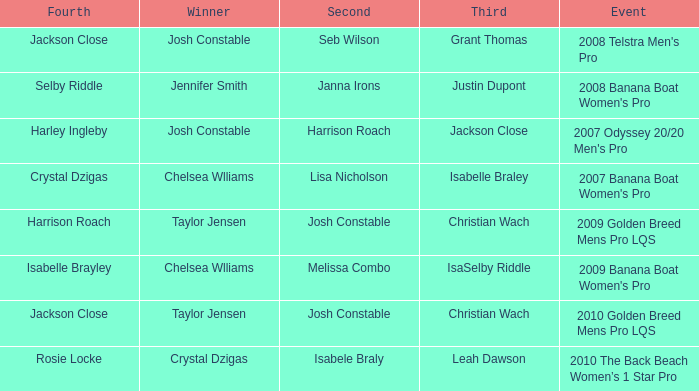Who was in Second Place with Isabelle Brayley came in Fourth? Melissa Combo. 